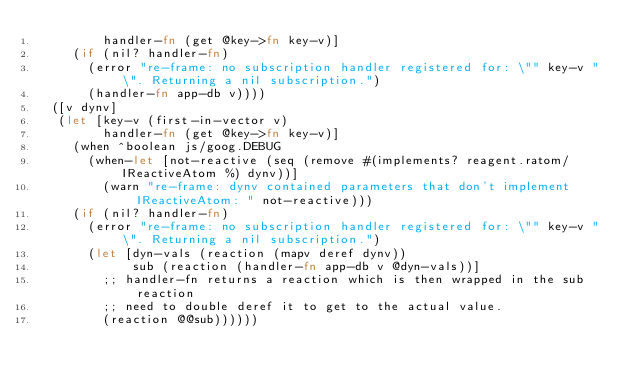Convert code to text. <code><loc_0><loc_0><loc_500><loc_500><_Clojure_>         handler-fn (get @key->fn key-v)]
     (if (nil? handler-fn)
       (error "re-frame: no subscription handler registered for: \"" key-v "\". Returning a nil subscription.")
       (handler-fn app-db v))))
  ([v dynv]
   (let [key-v (first-in-vector v)
         handler-fn (get @key->fn key-v)]
     (when ^boolean js/goog.DEBUG
       (when-let [not-reactive (seq (remove #(implements? reagent.ratom/IReactiveAtom %) dynv))]
         (warn "re-frame: dynv contained parameters that don't implement IReactiveAtom: " not-reactive)))
     (if (nil? handler-fn)
       (error "re-frame: no subscription handler registered for: \"" key-v "\". Returning a nil subscription.")
       (let [dyn-vals (reaction (mapv deref dynv))
             sub (reaction (handler-fn app-db v @dyn-vals))]
         ;; handler-fn returns a reaction which is then wrapped in the sub reaction
         ;; need to double deref it to get to the actual value.
         (reaction @@sub))))))
</code> 